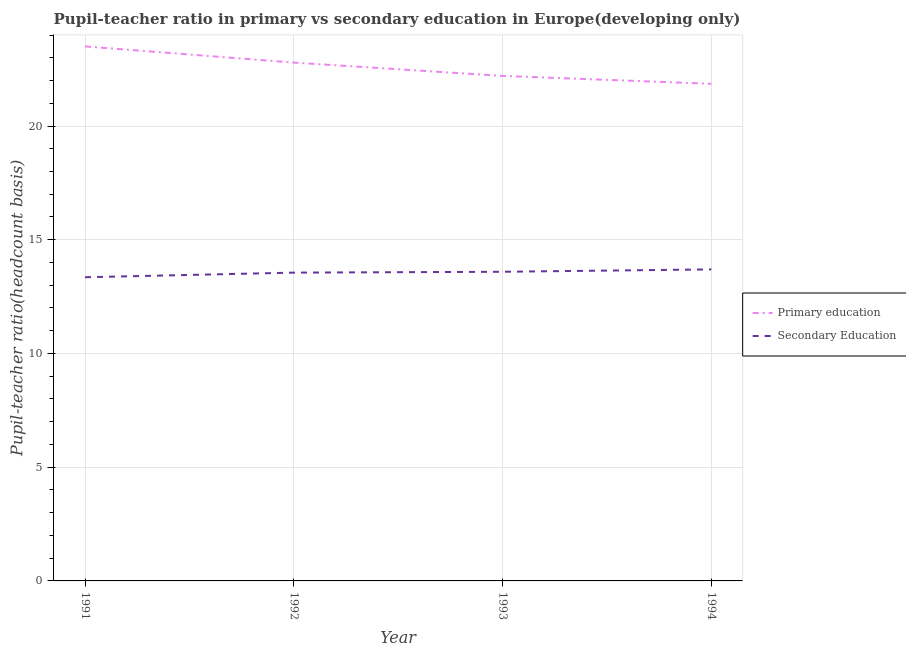How many different coloured lines are there?
Your response must be concise. 2. Is the number of lines equal to the number of legend labels?
Your answer should be very brief. Yes. What is the pupil teacher ratio on secondary education in 1992?
Your answer should be compact. 13.55. Across all years, what is the maximum pupil-teacher ratio in primary education?
Ensure brevity in your answer.  23.5. Across all years, what is the minimum pupil teacher ratio on secondary education?
Provide a succinct answer. 13.35. What is the total pupil-teacher ratio in primary education in the graph?
Offer a very short reply. 90.35. What is the difference between the pupil-teacher ratio in primary education in 1992 and that in 1993?
Ensure brevity in your answer.  0.59. What is the difference between the pupil-teacher ratio in primary education in 1994 and the pupil teacher ratio on secondary education in 1992?
Provide a succinct answer. 8.3. What is the average pupil-teacher ratio in primary education per year?
Your answer should be compact. 22.59. In the year 1993, what is the difference between the pupil-teacher ratio in primary education and pupil teacher ratio on secondary education?
Your answer should be compact. 8.61. What is the ratio of the pupil-teacher ratio in primary education in 1991 to that in 1992?
Your answer should be compact. 1.03. Is the difference between the pupil teacher ratio on secondary education in 1993 and 1994 greater than the difference between the pupil-teacher ratio in primary education in 1993 and 1994?
Provide a succinct answer. No. What is the difference between the highest and the second highest pupil-teacher ratio in primary education?
Keep it short and to the point. 0.71. What is the difference between the highest and the lowest pupil teacher ratio on secondary education?
Make the answer very short. 0.35. In how many years, is the pupil teacher ratio on secondary education greater than the average pupil teacher ratio on secondary education taken over all years?
Your answer should be very brief. 3. Is the sum of the pupil-teacher ratio in primary education in 1991 and 1994 greater than the maximum pupil teacher ratio on secondary education across all years?
Your answer should be compact. Yes. Does the pupil teacher ratio on secondary education monotonically increase over the years?
Ensure brevity in your answer.  Yes. Is the pupil-teacher ratio in primary education strictly greater than the pupil teacher ratio on secondary education over the years?
Provide a succinct answer. Yes. How many lines are there?
Your answer should be compact. 2. How many years are there in the graph?
Keep it short and to the point. 4. Are the values on the major ticks of Y-axis written in scientific E-notation?
Make the answer very short. No. Does the graph contain any zero values?
Offer a very short reply. No. Does the graph contain grids?
Give a very brief answer. Yes. How are the legend labels stacked?
Provide a short and direct response. Vertical. What is the title of the graph?
Offer a terse response. Pupil-teacher ratio in primary vs secondary education in Europe(developing only). Does "Secondary" appear as one of the legend labels in the graph?
Your answer should be very brief. No. What is the label or title of the Y-axis?
Your answer should be very brief. Pupil-teacher ratio(headcount basis). What is the Pupil-teacher ratio(headcount basis) in Primary education in 1991?
Your answer should be very brief. 23.5. What is the Pupil-teacher ratio(headcount basis) in Secondary Education in 1991?
Give a very brief answer. 13.35. What is the Pupil-teacher ratio(headcount basis) of Primary education in 1992?
Make the answer very short. 22.79. What is the Pupil-teacher ratio(headcount basis) in Secondary Education in 1992?
Offer a terse response. 13.55. What is the Pupil-teacher ratio(headcount basis) in Primary education in 1993?
Provide a succinct answer. 22.2. What is the Pupil-teacher ratio(headcount basis) of Secondary Education in 1993?
Make the answer very short. 13.59. What is the Pupil-teacher ratio(headcount basis) of Primary education in 1994?
Offer a terse response. 21.86. What is the Pupil-teacher ratio(headcount basis) in Secondary Education in 1994?
Make the answer very short. 13.7. Across all years, what is the maximum Pupil-teacher ratio(headcount basis) in Primary education?
Your response must be concise. 23.5. Across all years, what is the maximum Pupil-teacher ratio(headcount basis) in Secondary Education?
Provide a succinct answer. 13.7. Across all years, what is the minimum Pupil-teacher ratio(headcount basis) in Primary education?
Ensure brevity in your answer.  21.86. Across all years, what is the minimum Pupil-teacher ratio(headcount basis) of Secondary Education?
Provide a short and direct response. 13.35. What is the total Pupil-teacher ratio(headcount basis) of Primary education in the graph?
Your answer should be very brief. 90.35. What is the total Pupil-teacher ratio(headcount basis) in Secondary Education in the graph?
Offer a terse response. 54.19. What is the difference between the Pupil-teacher ratio(headcount basis) in Primary education in 1991 and that in 1992?
Make the answer very short. 0.71. What is the difference between the Pupil-teacher ratio(headcount basis) of Secondary Education in 1991 and that in 1992?
Your answer should be very brief. -0.2. What is the difference between the Pupil-teacher ratio(headcount basis) in Primary education in 1991 and that in 1993?
Offer a terse response. 1.3. What is the difference between the Pupil-teacher ratio(headcount basis) in Secondary Education in 1991 and that in 1993?
Provide a succinct answer. -0.24. What is the difference between the Pupil-teacher ratio(headcount basis) in Primary education in 1991 and that in 1994?
Your answer should be compact. 1.64. What is the difference between the Pupil-teacher ratio(headcount basis) in Secondary Education in 1991 and that in 1994?
Keep it short and to the point. -0.35. What is the difference between the Pupil-teacher ratio(headcount basis) in Primary education in 1992 and that in 1993?
Provide a short and direct response. 0.59. What is the difference between the Pupil-teacher ratio(headcount basis) of Secondary Education in 1992 and that in 1993?
Ensure brevity in your answer.  -0.04. What is the difference between the Pupil-teacher ratio(headcount basis) of Primary education in 1992 and that in 1994?
Make the answer very short. 0.93. What is the difference between the Pupil-teacher ratio(headcount basis) in Secondary Education in 1992 and that in 1994?
Make the answer very short. -0.14. What is the difference between the Pupil-teacher ratio(headcount basis) of Primary education in 1993 and that in 1994?
Offer a very short reply. 0.35. What is the difference between the Pupil-teacher ratio(headcount basis) of Secondary Education in 1993 and that in 1994?
Your response must be concise. -0.1. What is the difference between the Pupil-teacher ratio(headcount basis) in Primary education in 1991 and the Pupil-teacher ratio(headcount basis) in Secondary Education in 1992?
Give a very brief answer. 9.95. What is the difference between the Pupil-teacher ratio(headcount basis) of Primary education in 1991 and the Pupil-teacher ratio(headcount basis) of Secondary Education in 1993?
Offer a terse response. 9.91. What is the difference between the Pupil-teacher ratio(headcount basis) of Primary education in 1991 and the Pupil-teacher ratio(headcount basis) of Secondary Education in 1994?
Your response must be concise. 9.8. What is the difference between the Pupil-teacher ratio(headcount basis) of Primary education in 1992 and the Pupil-teacher ratio(headcount basis) of Secondary Education in 1993?
Keep it short and to the point. 9.2. What is the difference between the Pupil-teacher ratio(headcount basis) in Primary education in 1992 and the Pupil-teacher ratio(headcount basis) in Secondary Education in 1994?
Ensure brevity in your answer.  9.09. What is the difference between the Pupil-teacher ratio(headcount basis) in Primary education in 1993 and the Pupil-teacher ratio(headcount basis) in Secondary Education in 1994?
Your answer should be compact. 8.51. What is the average Pupil-teacher ratio(headcount basis) of Primary education per year?
Provide a short and direct response. 22.59. What is the average Pupil-teacher ratio(headcount basis) in Secondary Education per year?
Make the answer very short. 13.55. In the year 1991, what is the difference between the Pupil-teacher ratio(headcount basis) in Primary education and Pupil-teacher ratio(headcount basis) in Secondary Education?
Your answer should be compact. 10.15. In the year 1992, what is the difference between the Pupil-teacher ratio(headcount basis) in Primary education and Pupil-teacher ratio(headcount basis) in Secondary Education?
Provide a succinct answer. 9.23. In the year 1993, what is the difference between the Pupil-teacher ratio(headcount basis) of Primary education and Pupil-teacher ratio(headcount basis) of Secondary Education?
Give a very brief answer. 8.61. In the year 1994, what is the difference between the Pupil-teacher ratio(headcount basis) in Primary education and Pupil-teacher ratio(headcount basis) in Secondary Education?
Ensure brevity in your answer.  8.16. What is the ratio of the Pupil-teacher ratio(headcount basis) in Primary education in 1991 to that in 1992?
Offer a terse response. 1.03. What is the ratio of the Pupil-teacher ratio(headcount basis) in Primary education in 1991 to that in 1993?
Your answer should be very brief. 1.06. What is the ratio of the Pupil-teacher ratio(headcount basis) in Secondary Education in 1991 to that in 1993?
Your answer should be compact. 0.98. What is the ratio of the Pupil-teacher ratio(headcount basis) of Primary education in 1991 to that in 1994?
Keep it short and to the point. 1.08. What is the ratio of the Pupil-teacher ratio(headcount basis) of Secondary Education in 1991 to that in 1994?
Your response must be concise. 0.97. What is the ratio of the Pupil-teacher ratio(headcount basis) of Primary education in 1992 to that in 1993?
Your answer should be compact. 1.03. What is the ratio of the Pupil-teacher ratio(headcount basis) of Primary education in 1992 to that in 1994?
Provide a succinct answer. 1.04. What is the ratio of the Pupil-teacher ratio(headcount basis) in Primary education in 1993 to that in 1994?
Provide a short and direct response. 1.02. What is the ratio of the Pupil-teacher ratio(headcount basis) of Secondary Education in 1993 to that in 1994?
Provide a succinct answer. 0.99. What is the difference between the highest and the second highest Pupil-teacher ratio(headcount basis) in Primary education?
Make the answer very short. 0.71. What is the difference between the highest and the second highest Pupil-teacher ratio(headcount basis) of Secondary Education?
Provide a short and direct response. 0.1. What is the difference between the highest and the lowest Pupil-teacher ratio(headcount basis) of Primary education?
Provide a short and direct response. 1.64. What is the difference between the highest and the lowest Pupil-teacher ratio(headcount basis) in Secondary Education?
Offer a very short reply. 0.35. 